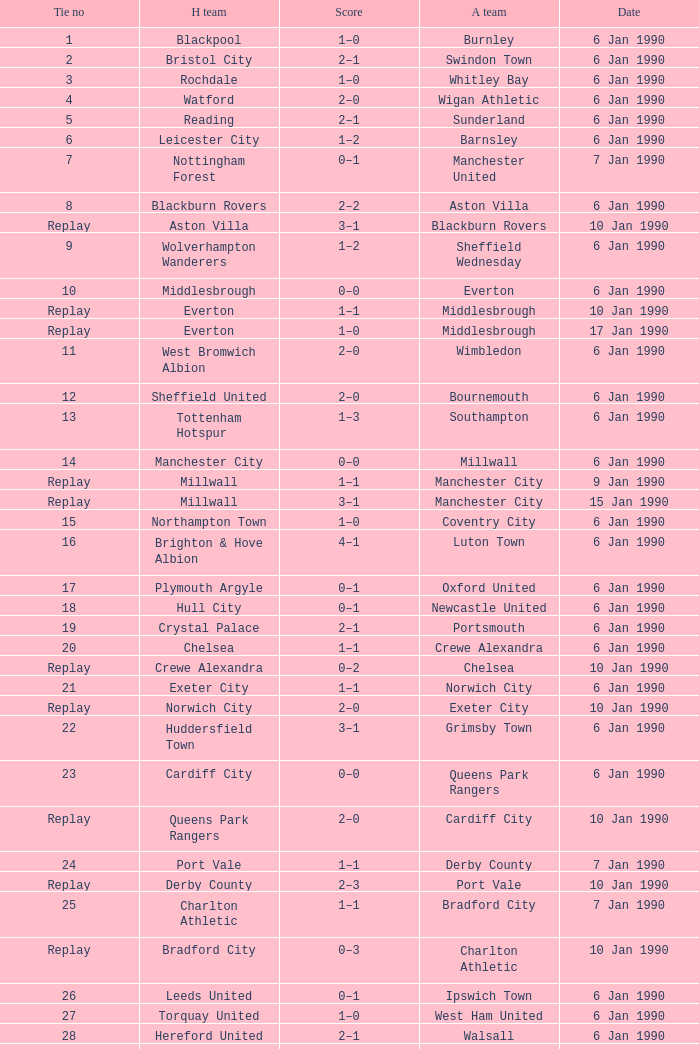What is the tie no of the game where exeter city was the home team? 21.0. Write the full table. {'header': ['Tie no', 'H team', 'Score', 'A team', 'Date'], 'rows': [['1', 'Blackpool', '1–0', 'Burnley', '6 Jan 1990'], ['2', 'Bristol City', '2–1', 'Swindon Town', '6 Jan 1990'], ['3', 'Rochdale', '1–0', 'Whitley Bay', '6 Jan 1990'], ['4', 'Watford', '2–0', 'Wigan Athletic', '6 Jan 1990'], ['5', 'Reading', '2–1', 'Sunderland', '6 Jan 1990'], ['6', 'Leicester City', '1–2', 'Barnsley', '6 Jan 1990'], ['7', 'Nottingham Forest', '0–1', 'Manchester United', '7 Jan 1990'], ['8', 'Blackburn Rovers', '2–2', 'Aston Villa', '6 Jan 1990'], ['Replay', 'Aston Villa', '3–1', 'Blackburn Rovers', '10 Jan 1990'], ['9', 'Wolverhampton Wanderers', '1–2', 'Sheffield Wednesday', '6 Jan 1990'], ['10', 'Middlesbrough', '0–0', 'Everton', '6 Jan 1990'], ['Replay', 'Everton', '1–1', 'Middlesbrough', '10 Jan 1990'], ['Replay', 'Everton', '1–0', 'Middlesbrough', '17 Jan 1990'], ['11', 'West Bromwich Albion', '2–0', 'Wimbledon', '6 Jan 1990'], ['12', 'Sheffield United', '2–0', 'Bournemouth', '6 Jan 1990'], ['13', 'Tottenham Hotspur', '1–3', 'Southampton', '6 Jan 1990'], ['14', 'Manchester City', '0–0', 'Millwall', '6 Jan 1990'], ['Replay', 'Millwall', '1–1', 'Manchester City', '9 Jan 1990'], ['Replay', 'Millwall', '3–1', 'Manchester City', '15 Jan 1990'], ['15', 'Northampton Town', '1–0', 'Coventry City', '6 Jan 1990'], ['16', 'Brighton & Hove Albion', '4–1', 'Luton Town', '6 Jan 1990'], ['17', 'Plymouth Argyle', '0–1', 'Oxford United', '6 Jan 1990'], ['18', 'Hull City', '0–1', 'Newcastle United', '6 Jan 1990'], ['19', 'Crystal Palace', '2–1', 'Portsmouth', '6 Jan 1990'], ['20', 'Chelsea', '1–1', 'Crewe Alexandra', '6 Jan 1990'], ['Replay', 'Crewe Alexandra', '0–2', 'Chelsea', '10 Jan 1990'], ['21', 'Exeter City', '1–1', 'Norwich City', '6 Jan 1990'], ['Replay', 'Norwich City', '2–0', 'Exeter City', '10 Jan 1990'], ['22', 'Huddersfield Town', '3–1', 'Grimsby Town', '6 Jan 1990'], ['23', 'Cardiff City', '0–0', 'Queens Park Rangers', '6 Jan 1990'], ['Replay', 'Queens Park Rangers', '2–0', 'Cardiff City', '10 Jan 1990'], ['24', 'Port Vale', '1–1', 'Derby County', '7 Jan 1990'], ['Replay', 'Derby County', '2–3', 'Port Vale', '10 Jan 1990'], ['25', 'Charlton Athletic', '1–1', 'Bradford City', '7 Jan 1990'], ['Replay', 'Bradford City', '0–3', 'Charlton Athletic', '10 Jan 1990'], ['26', 'Leeds United', '0–1', 'Ipswich Town', '6 Jan 1990'], ['27', 'Torquay United', '1–0', 'West Ham United', '6 Jan 1990'], ['28', 'Hereford United', '2–1', 'Walsall', '6 Jan 1990'], ['29', 'Stoke City', '0–1', 'Arsenal', '6 Jan 1990'], ['30', 'Birmingham City', '1–1', 'Oldham Athletic', '6 Jan 1990'], ['Replay', 'Oldham Athletic', '1–0', 'Birmingham City', '10 Jan 1990'], ['31', 'Cambridge United', '0–0', 'Darlington', '6 Jan 1990'], ['Replay', 'Darlington', '1–3', 'Cambridge United', '9 Jan 1990'], ['32', 'Swansea City', '0–0', 'Liverpool', '6 Jan 1990'], ['Replay', 'Liverpool', '8–0', 'Swansea City', '9 Jan 1990']]} 